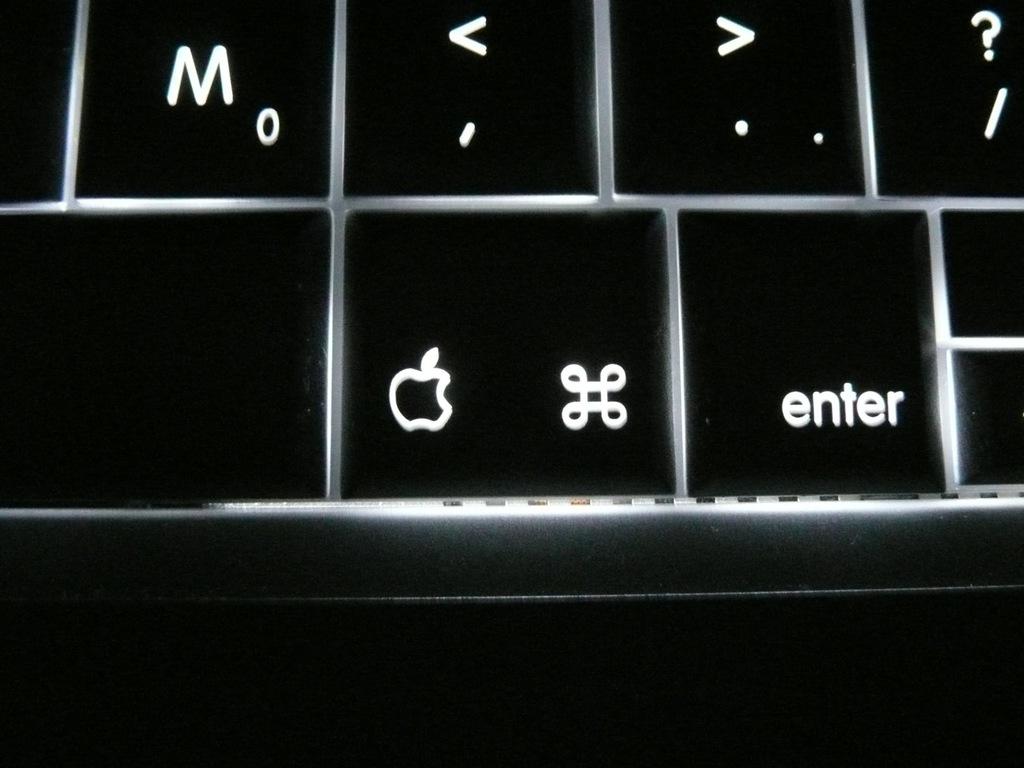What brand of laptop is this?
Give a very brief answer. Apple. What does the right key say?
Give a very brief answer. Enter. 